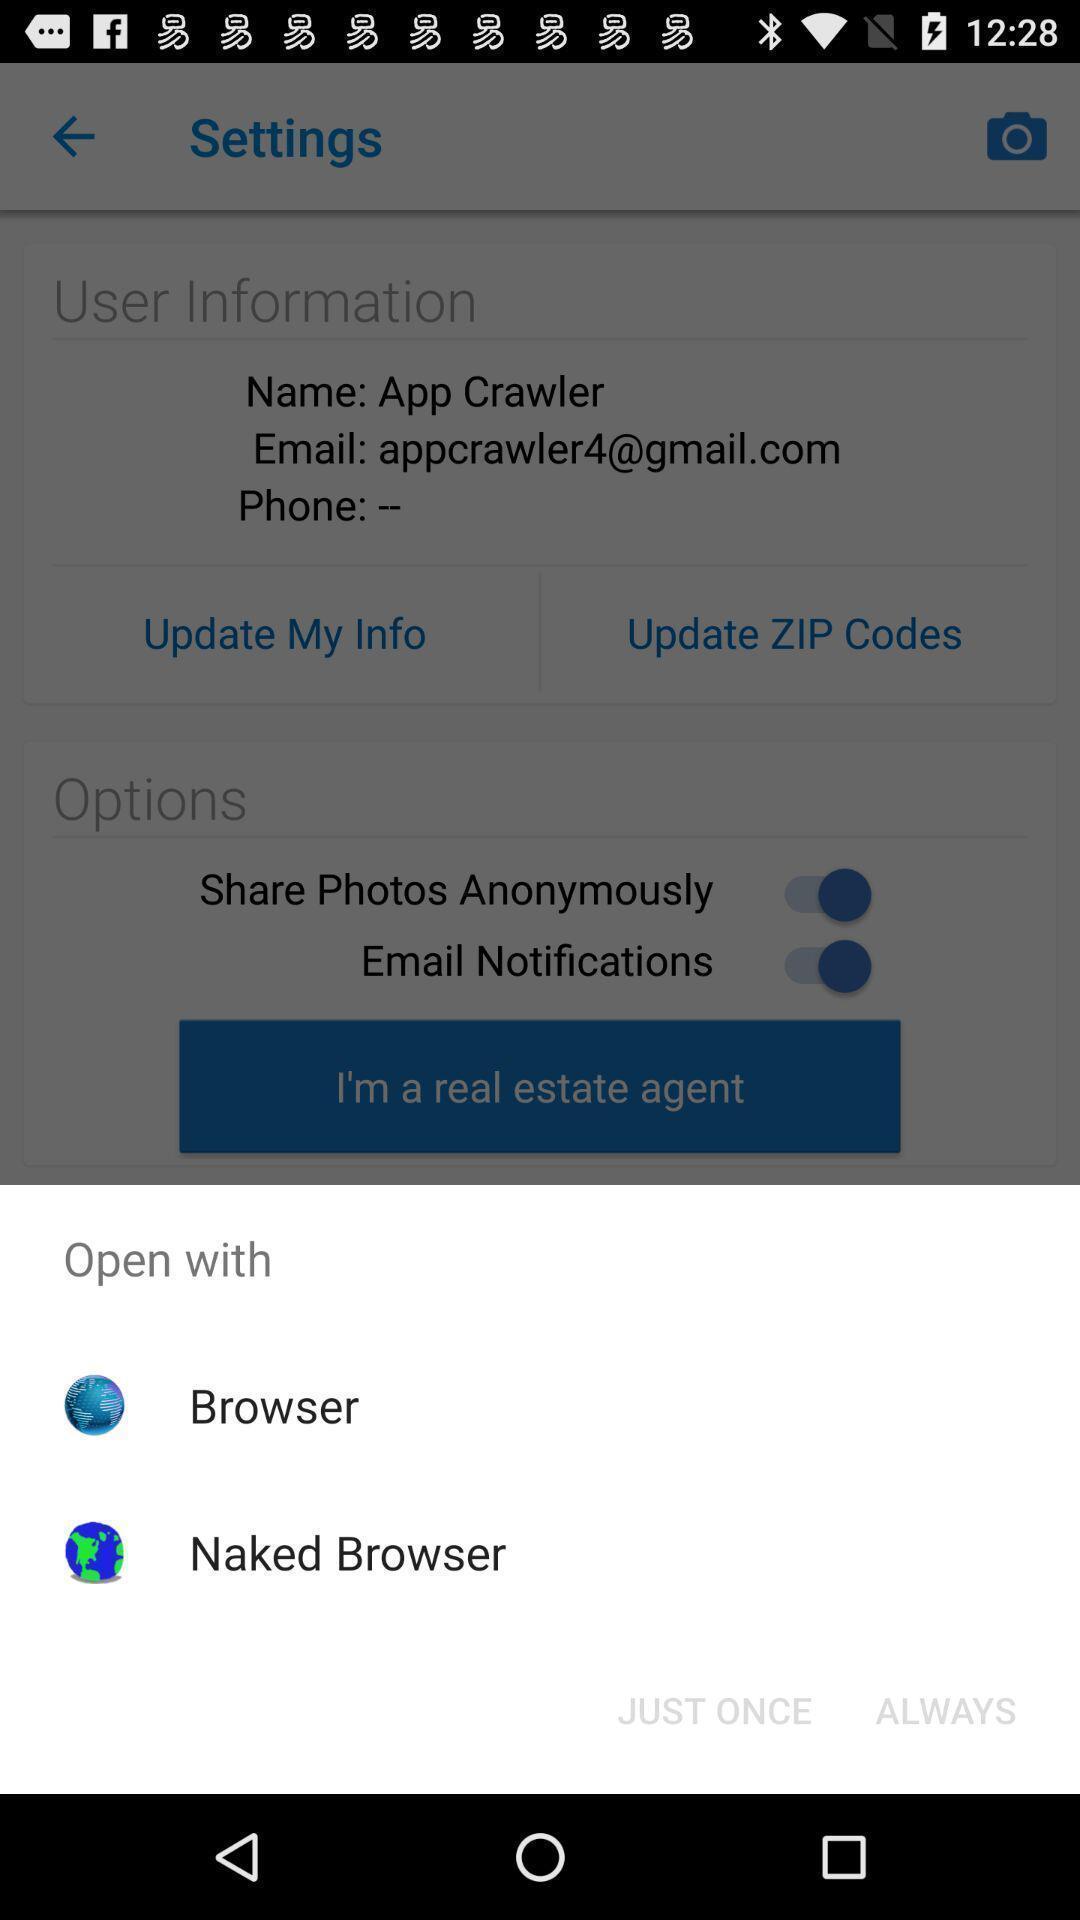Explain what's happening in this screen capture. Popup showing open option to browser. 